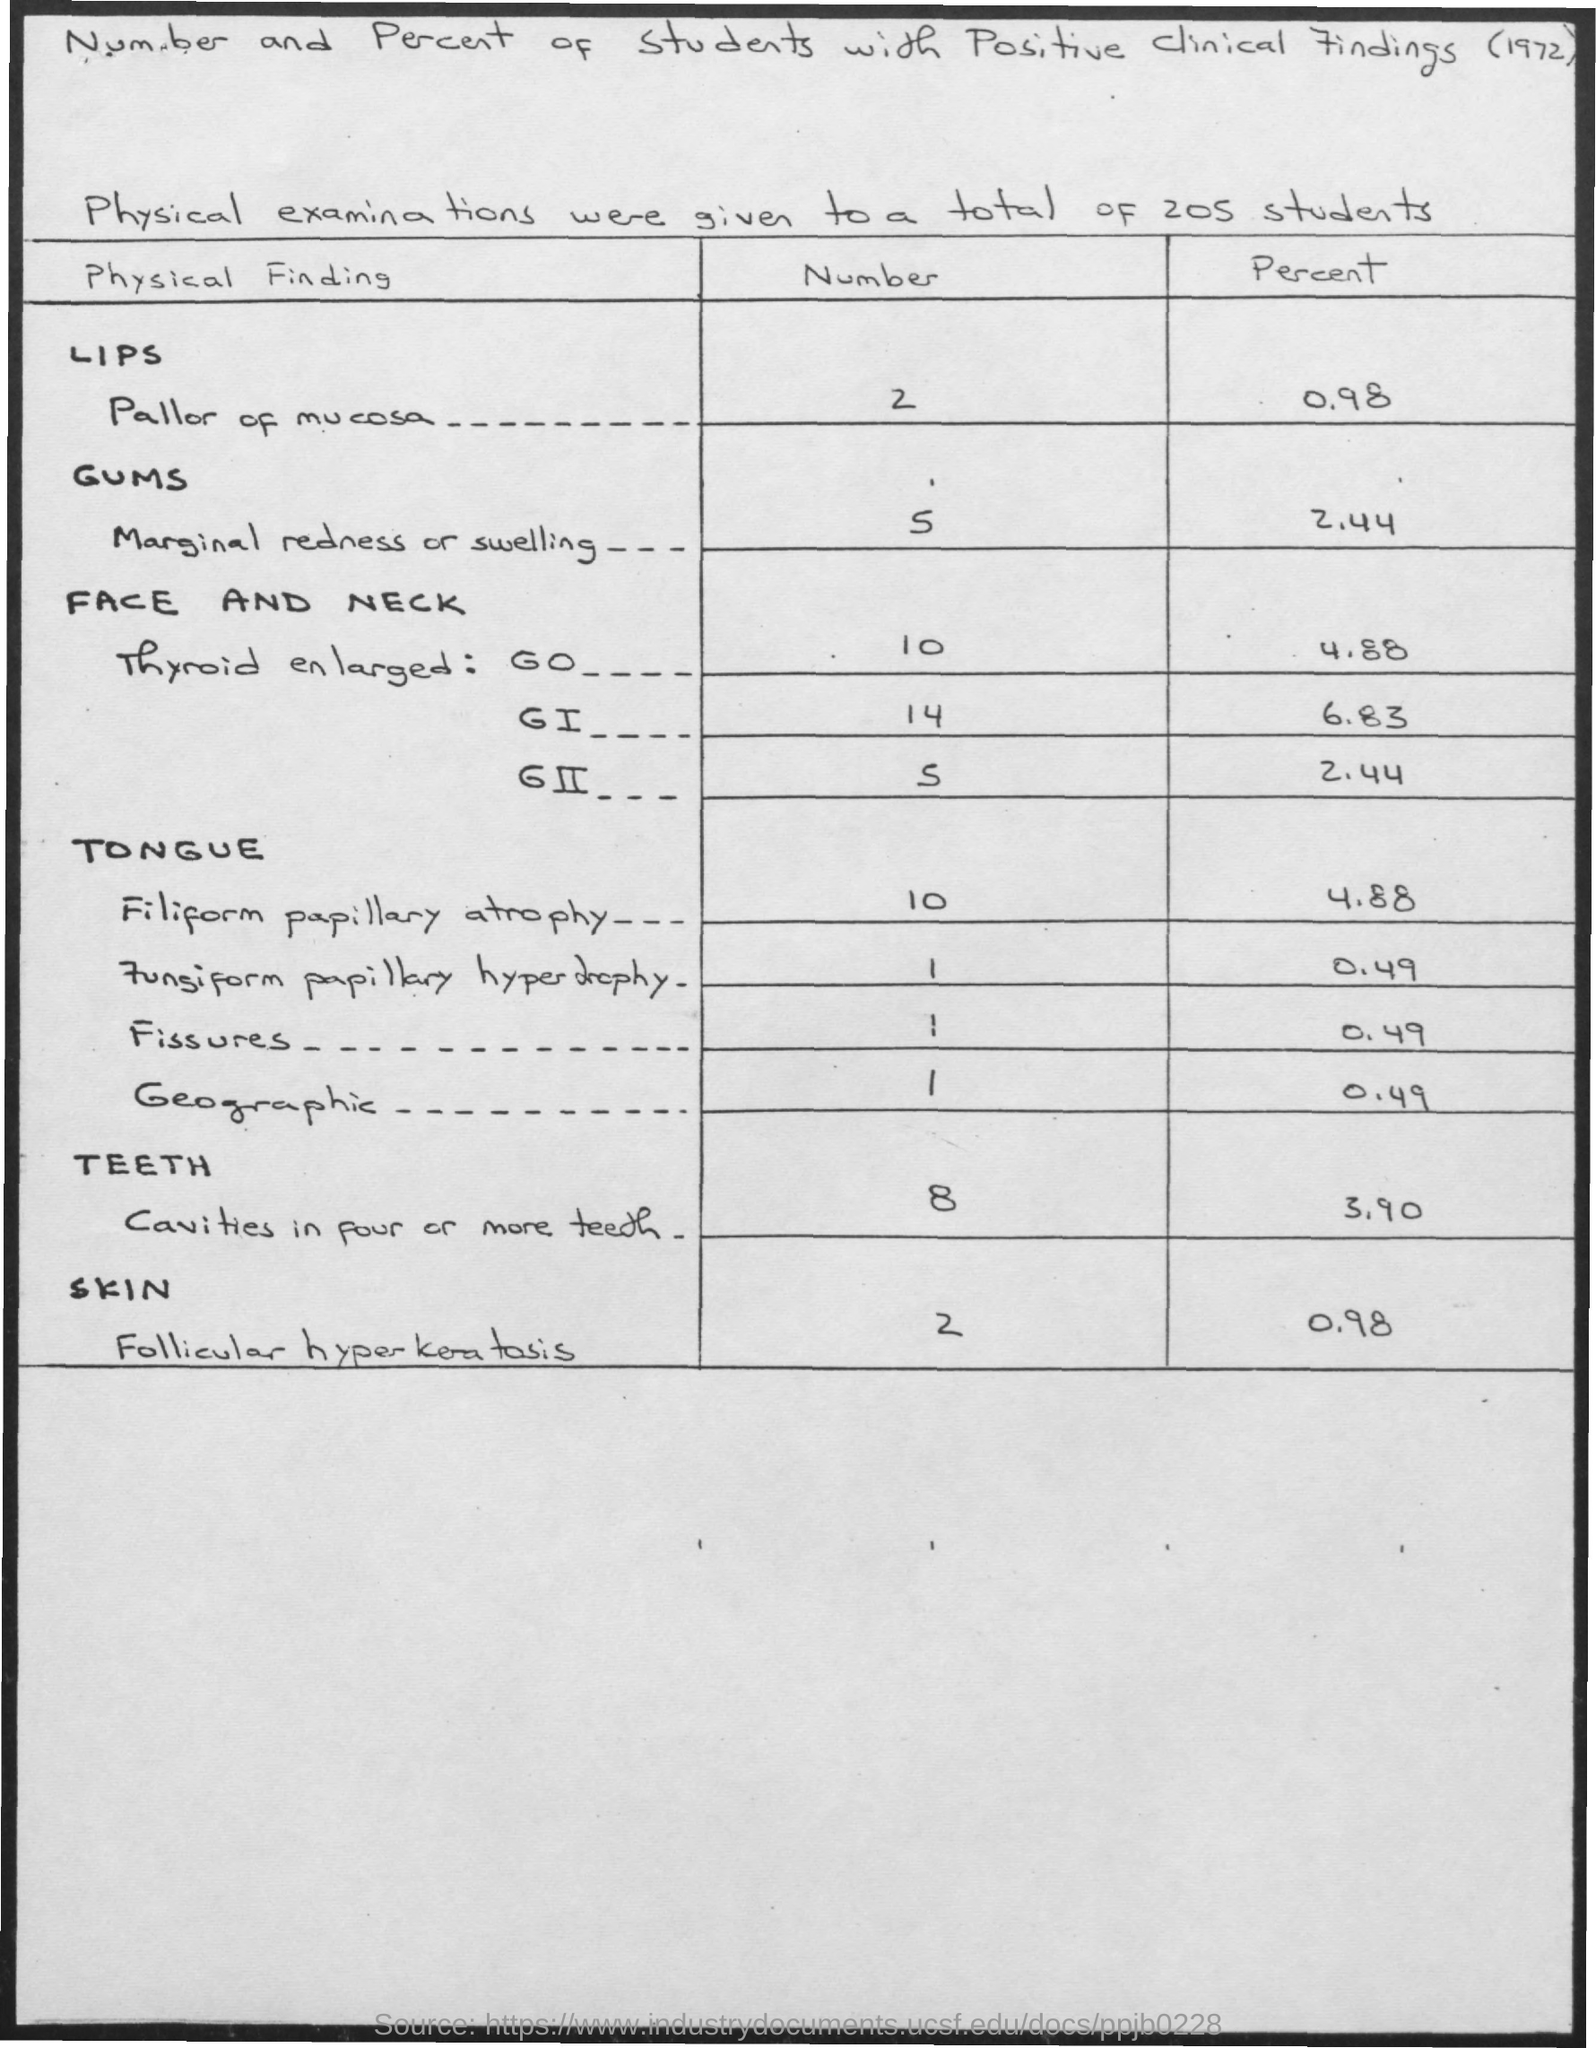List a handful of essential elements in this visual. Out of the individuals examined, 10% were found to have an enlarged thyroid gland, as determined by the study. A thyroid gland with an enlarged size was found in 4.88% of the individuals examined. It was found that 5 individuals had an enlarged thyroid gland among the group of individuals whose results are reported in this study. Five patients exhibited marginal redness or swelling. Of the patients screened, two were found to have a pale or white appearance to the mucous membranes around their lips, indicating potential methemoglobinemia. 